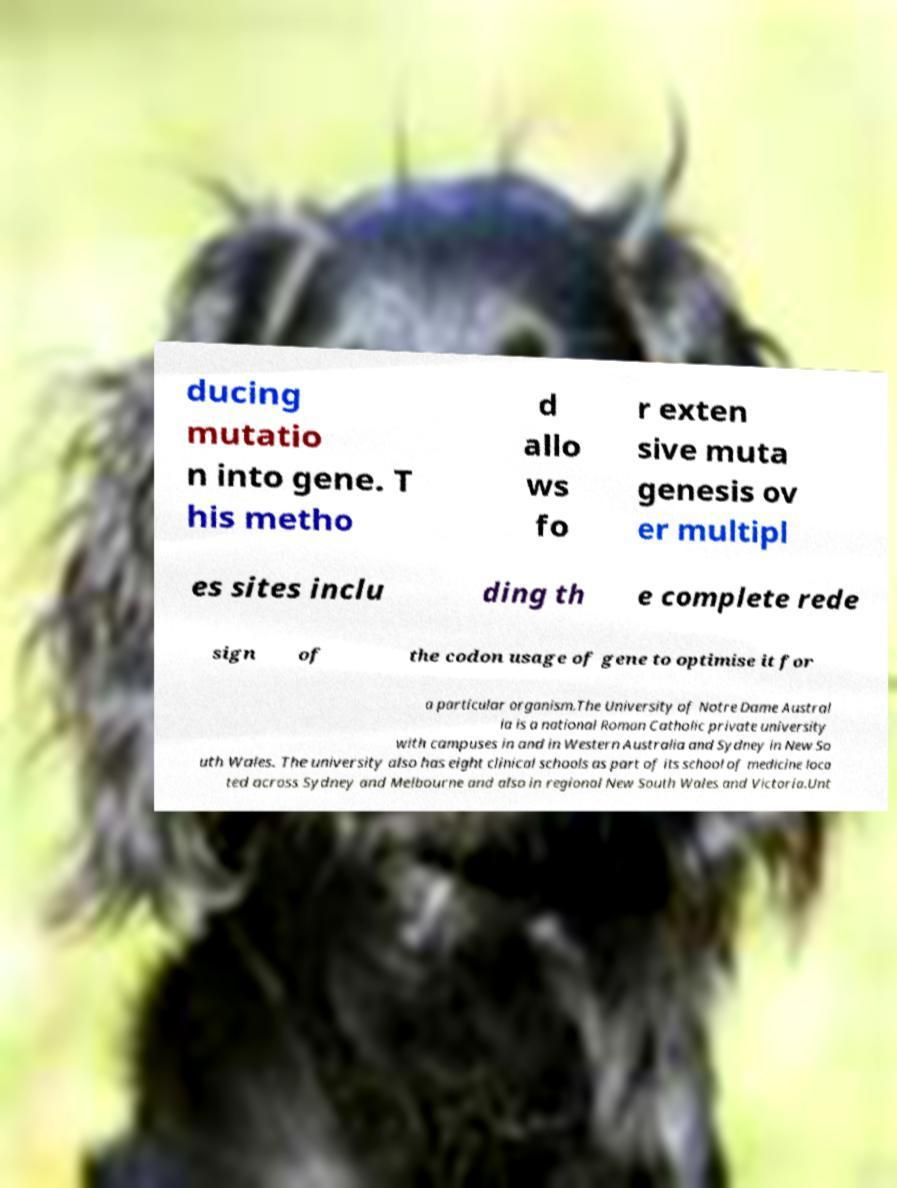Please read and relay the text visible in this image. What does it say? ducing mutatio n into gene. T his metho d allo ws fo r exten sive muta genesis ov er multipl es sites inclu ding th e complete rede sign of the codon usage of gene to optimise it for a particular organism.The University of Notre Dame Austral ia is a national Roman Catholic private university with campuses in and in Western Australia and Sydney in New So uth Wales. The university also has eight clinical schools as part of its school of medicine loca ted across Sydney and Melbourne and also in regional New South Wales and Victoria.Unt 